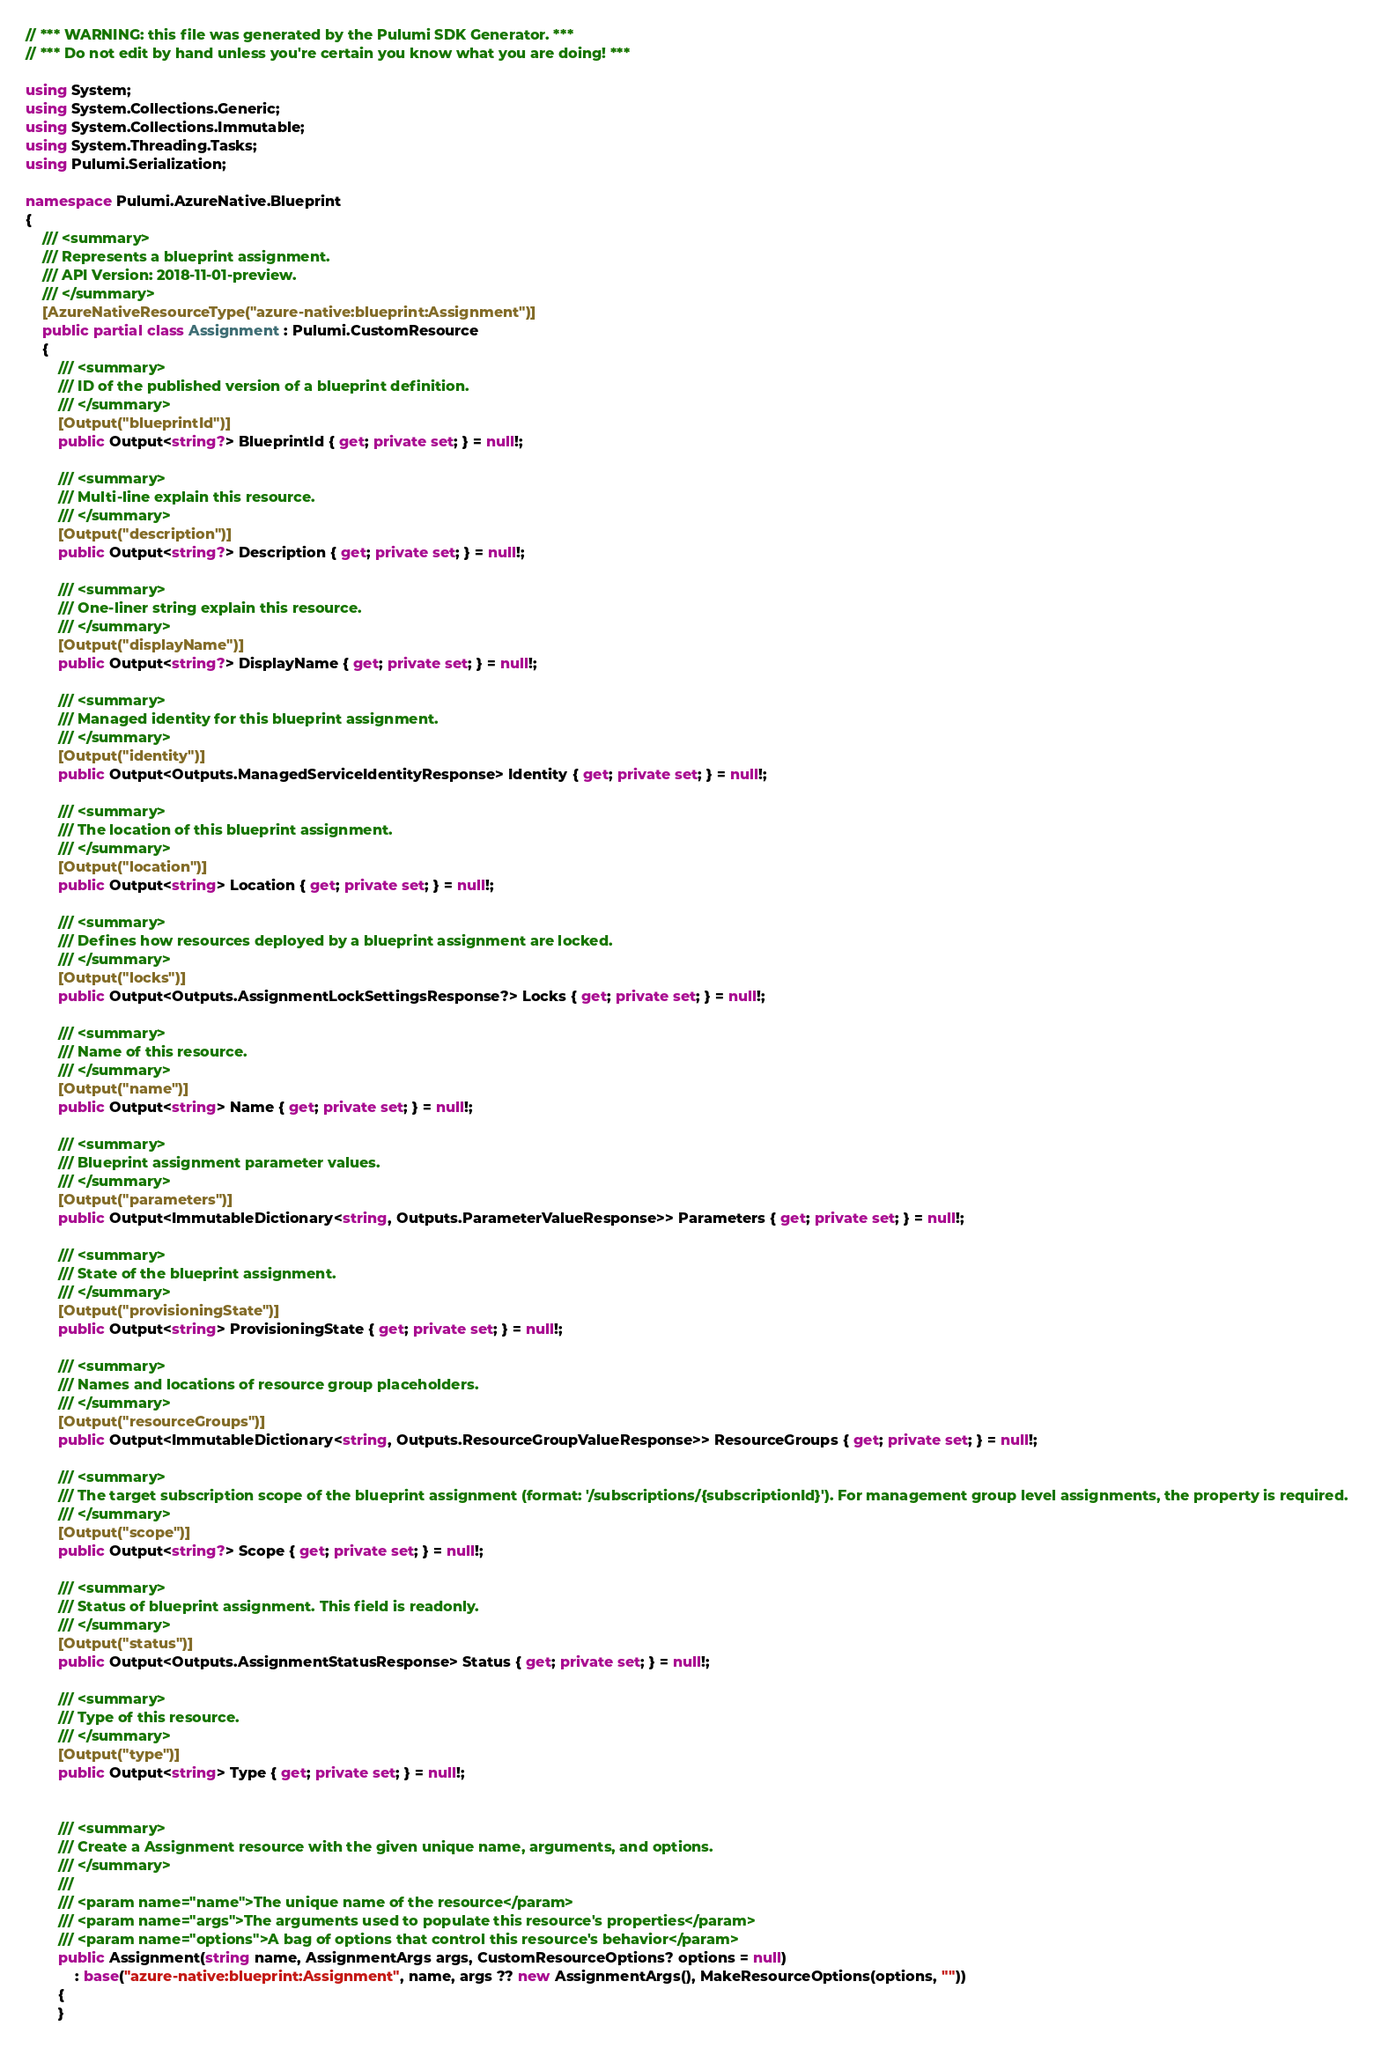Convert code to text. <code><loc_0><loc_0><loc_500><loc_500><_C#_>// *** WARNING: this file was generated by the Pulumi SDK Generator. ***
// *** Do not edit by hand unless you're certain you know what you are doing! ***

using System;
using System.Collections.Generic;
using System.Collections.Immutable;
using System.Threading.Tasks;
using Pulumi.Serialization;

namespace Pulumi.AzureNative.Blueprint
{
    /// <summary>
    /// Represents a blueprint assignment.
    /// API Version: 2018-11-01-preview.
    /// </summary>
    [AzureNativeResourceType("azure-native:blueprint:Assignment")]
    public partial class Assignment : Pulumi.CustomResource
    {
        /// <summary>
        /// ID of the published version of a blueprint definition.
        /// </summary>
        [Output("blueprintId")]
        public Output<string?> BlueprintId { get; private set; } = null!;

        /// <summary>
        /// Multi-line explain this resource.
        /// </summary>
        [Output("description")]
        public Output<string?> Description { get; private set; } = null!;

        /// <summary>
        /// One-liner string explain this resource.
        /// </summary>
        [Output("displayName")]
        public Output<string?> DisplayName { get; private set; } = null!;

        /// <summary>
        /// Managed identity for this blueprint assignment.
        /// </summary>
        [Output("identity")]
        public Output<Outputs.ManagedServiceIdentityResponse> Identity { get; private set; } = null!;

        /// <summary>
        /// The location of this blueprint assignment.
        /// </summary>
        [Output("location")]
        public Output<string> Location { get; private set; } = null!;

        /// <summary>
        /// Defines how resources deployed by a blueprint assignment are locked.
        /// </summary>
        [Output("locks")]
        public Output<Outputs.AssignmentLockSettingsResponse?> Locks { get; private set; } = null!;

        /// <summary>
        /// Name of this resource.
        /// </summary>
        [Output("name")]
        public Output<string> Name { get; private set; } = null!;

        /// <summary>
        /// Blueprint assignment parameter values.
        /// </summary>
        [Output("parameters")]
        public Output<ImmutableDictionary<string, Outputs.ParameterValueResponse>> Parameters { get; private set; } = null!;

        /// <summary>
        /// State of the blueprint assignment.
        /// </summary>
        [Output("provisioningState")]
        public Output<string> ProvisioningState { get; private set; } = null!;

        /// <summary>
        /// Names and locations of resource group placeholders.
        /// </summary>
        [Output("resourceGroups")]
        public Output<ImmutableDictionary<string, Outputs.ResourceGroupValueResponse>> ResourceGroups { get; private set; } = null!;

        /// <summary>
        /// The target subscription scope of the blueprint assignment (format: '/subscriptions/{subscriptionId}'). For management group level assignments, the property is required.
        /// </summary>
        [Output("scope")]
        public Output<string?> Scope { get; private set; } = null!;

        /// <summary>
        /// Status of blueprint assignment. This field is readonly.
        /// </summary>
        [Output("status")]
        public Output<Outputs.AssignmentStatusResponse> Status { get; private set; } = null!;

        /// <summary>
        /// Type of this resource.
        /// </summary>
        [Output("type")]
        public Output<string> Type { get; private set; } = null!;


        /// <summary>
        /// Create a Assignment resource with the given unique name, arguments, and options.
        /// </summary>
        ///
        /// <param name="name">The unique name of the resource</param>
        /// <param name="args">The arguments used to populate this resource's properties</param>
        /// <param name="options">A bag of options that control this resource's behavior</param>
        public Assignment(string name, AssignmentArgs args, CustomResourceOptions? options = null)
            : base("azure-native:blueprint:Assignment", name, args ?? new AssignmentArgs(), MakeResourceOptions(options, ""))
        {
        }
</code> 